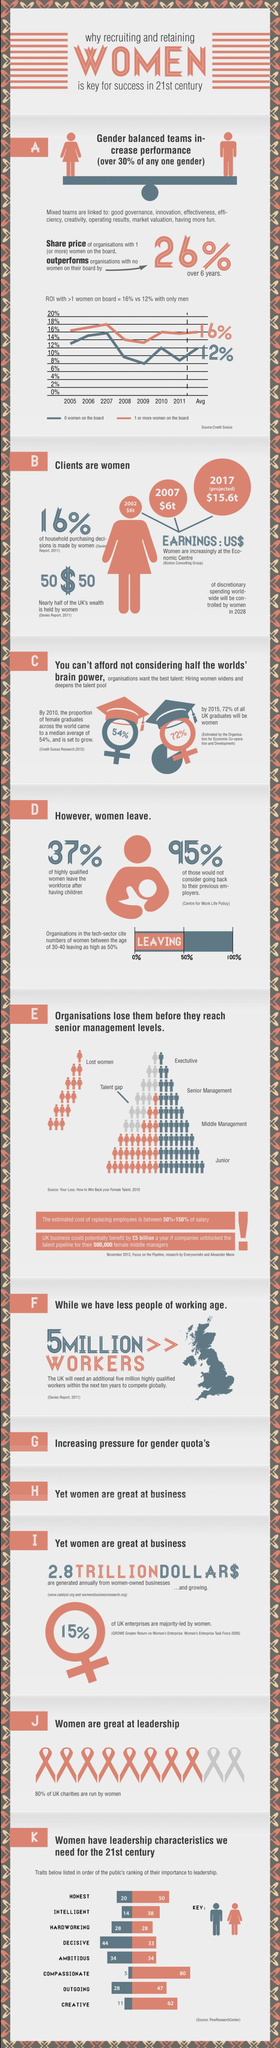Specify some key components in this picture. A significant number of women in the tech sector leave their jobs, with approximately 50% of them choosing to exit their positions. It is my belief that hard work is the weakest leadership trait in women. The cost of filling the talent gap can range from 50% to 150% of the employee's salary. Men are generally considered to be stronger in the trait of decisiveness than women, according to research. In both men and women, hardworking and ambitious leadership traits are considered to be equal. 